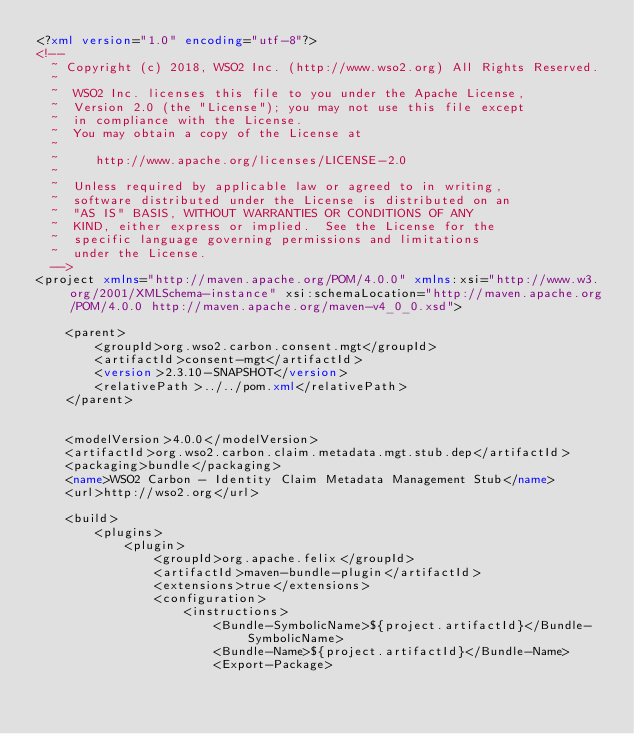Convert code to text. <code><loc_0><loc_0><loc_500><loc_500><_XML_><?xml version="1.0" encoding="utf-8"?>
<!--
  ~ Copyright (c) 2018, WSO2 Inc. (http://www.wso2.org) All Rights Reserved.
  ~
  ~  WSO2 Inc. licenses this file to you under the Apache License,
  ~  Version 2.0 (the "License"); you may not use this file except
  ~  in compliance with the License.
  ~  You may obtain a copy of the License at
  ~
  ~     http://www.apache.org/licenses/LICENSE-2.0
  ~
  ~  Unless required by applicable law or agreed to in writing,
  ~  software distributed under the License is distributed on an
  ~  "AS IS" BASIS, WITHOUT WARRANTIES OR CONDITIONS OF ANY
  ~  KIND, either express or implied.  See the License for the
  ~  specific language governing permissions and limitations
  ~  under the License.
  -->
<project xmlns="http://maven.apache.org/POM/4.0.0" xmlns:xsi="http://www.w3.org/2001/XMLSchema-instance" xsi:schemaLocation="http://maven.apache.org/POM/4.0.0 http://maven.apache.org/maven-v4_0_0.xsd">

    <parent>
        <groupId>org.wso2.carbon.consent.mgt</groupId>
        <artifactId>consent-mgt</artifactId>
        <version>2.3.10-SNAPSHOT</version>
        <relativePath>../../pom.xml</relativePath>
    </parent>


    <modelVersion>4.0.0</modelVersion>
    <artifactId>org.wso2.carbon.claim.metadata.mgt.stub.dep</artifactId>
    <packaging>bundle</packaging>
    <name>WSO2 Carbon - Identity Claim Metadata Management Stub</name>
    <url>http://wso2.org</url>

    <build>
        <plugins>
            <plugin>
                <groupId>org.apache.felix</groupId>
                <artifactId>maven-bundle-plugin</artifactId>
                <extensions>true</extensions>
                <configuration>
                    <instructions>
                        <Bundle-SymbolicName>${project.artifactId}</Bundle-SymbolicName>
                        <Bundle-Name>${project.artifactId}</Bundle-Name>
                        <Export-Package></code> 